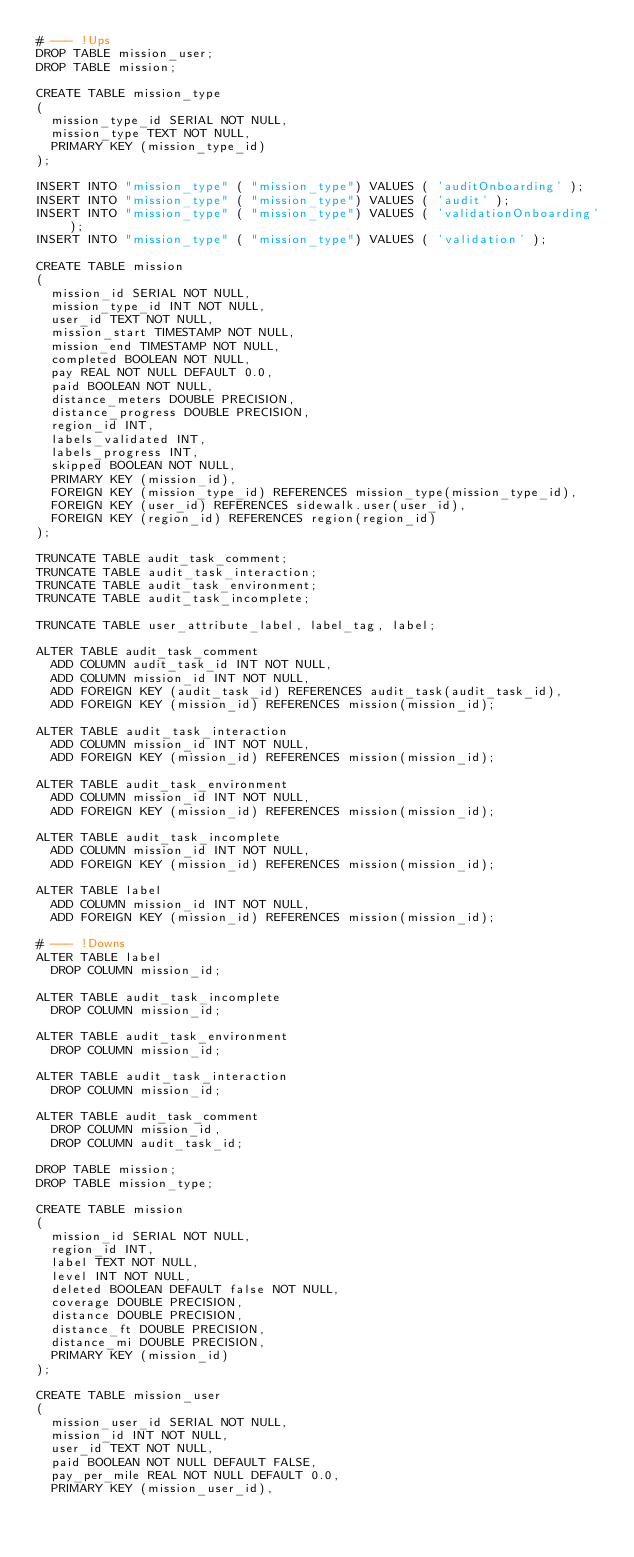<code> <loc_0><loc_0><loc_500><loc_500><_SQL_># --- !Ups
DROP TABLE mission_user;
DROP TABLE mission;

CREATE TABLE mission_type
(
  mission_type_id SERIAL NOT NULL,
  mission_type TEXT NOT NULL,
  PRIMARY KEY (mission_type_id)
);

INSERT INTO "mission_type" ( "mission_type") VALUES ( 'auditOnboarding' );
INSERT INTO "mission_type" ( "mission_type") VALUES ( 'audit' );
INSERT INTO "mission_type" ( "mission_type") VALUES ( 'validationOnboarding' );
INSERT INTO "mission_type" ( "mission_type") VALUES ( 'validation' );

CREATE TABLE mission
(
  mission_id SERIAL NOT NULL,
  mission_type_id INT NOT NULL,
  user_id TEXT NOT NULL,
  mission_start TIMESTAMP NOT NULL,
  mission_end TIMESTAMP NOT NULL,
  completed BOOLEAN NOT NULL,
  pay REAL NOT NULL DEFAULT 0.0,
  paid BOOLEAN NOT NULL,
  distance_meters DOUBLE PRECISION,
  distance_progress DOUBLE PRECISION,
  region_id INT,
  labels_validated INT,
  labels_progress INT,
  skipped BOOLEAN NOT NULL,
  PRIMARY KEY (mission_id),
  FOREIGN KEY (mission_type_id) REFERENCES mission_type(mission_type_id),
  FOREIGN KEY (user_id) REFERENCES sidewalk.user(user_id),
  FOREIGN KEY (region_id) REFERENCES region(region_id)
);

TRUNCATE TABLE audit_task_comment;
TRUNCATE TABLE audit_task_interaction;
TRUNCATE TABLE audit_task_environment;
TRUNCATE TABLE audit_task_incomplete;

TRUNCATE TABLE user_attribute_label, label_tag, label;

ALTER TABLE audit_task_comment
  ADD COLUMN audit_task_id INT NOT NULL,
  ADD COLUMN mission_id INT NOT NULL,
  ADD FOREIGN KEY (audit_task_id) REFERENCES audit_task(audit_task_id),
  ADD FOREIGN KEY (mission_id) REFERENCES mission(mission_id);

ALTER TABLE audit_task_interaction
  ADD COLUMN mission_id INT NOT NULL,
  ADD FOREIGN KEY (mission_id) REFERENCES mission(mission_id);

ALTER TABLE audit_task_environment
  ADD COLUMN mission_id INT NOT NULL,
  ADD FOREIGN KEY (mission_id) REFERENCES mission(mission_id);

ALTER TABLE audit_task_incomplete
  ADD COLUMN mission_id INT NOT NULL,
  ADD FOREIGN KEY (mission_id) REFERENCES mission(mission_id);

ALTER TABLE label
  ADD COLUMN mission_id INT NOT NULL,
  ADD FOREIGN KEY (mission_id) REFERENCES mission(mission_id);

# --- !Downs
ALTER TABLE label
  DROP COLUMN mission_id;

ALTER TABLE audit_task_incomplete
  DROP COLUMN mission_id;

ALTER TABLE audit_task_environment
  DROP COLUMN mission_id;

ALTER TABLE audit_task_interaction
  DROP COLUMN mission_id;

ALTER TABLE audit_task_comment
  DROP COLUMN mission_id,
  DROP COLUMN audit_task_id;

DROP TABLE mission;
DROP TABLE mission_type;

CREATE TABLE mission
(
  mission_id SERIAL NOT NULL,
  region_id INT,
  label TEXT NOT NULL,
  level INT NOT NULL,
  deleted BOOLEAN DEFAULT false NOT NULL,
  coverage DOUBLE PRECISION,
  distance DOUBLE PRECISION,
  distance_ft DOUBLE PRECISION,
  distance_mi DOUBLE PRECISION,
  PRIMARY KEY (mission_id)
);

CREATE TABLE mission_user
(
  mission_user_id SERIAL NOT NULL,
  mission_id INT NOT NULL,
  user_id TEXT NOT NULL,
  paid BOOLEAN NOT NULL DEFAULT FALSE,
  pay_per_mile REAL NOT NULL DEFAULT 0.0,
  PRIMARY KEY (mission_user_id),</code> 